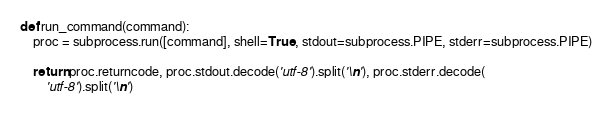Convert code to text. <code><loc_0><loc_0><loc_500><loc_500><_Python_>def run_command(command):
    proc = subprocess.run([command], shell=True, stdout=subprocess.PIPE, stderr=subprocess.PIPE)

    return proc.returncode, proc.stdout.decode('utf-8').split('\n'), proc.stderr.decode(
        'utf-8').split('\n')
</code> 